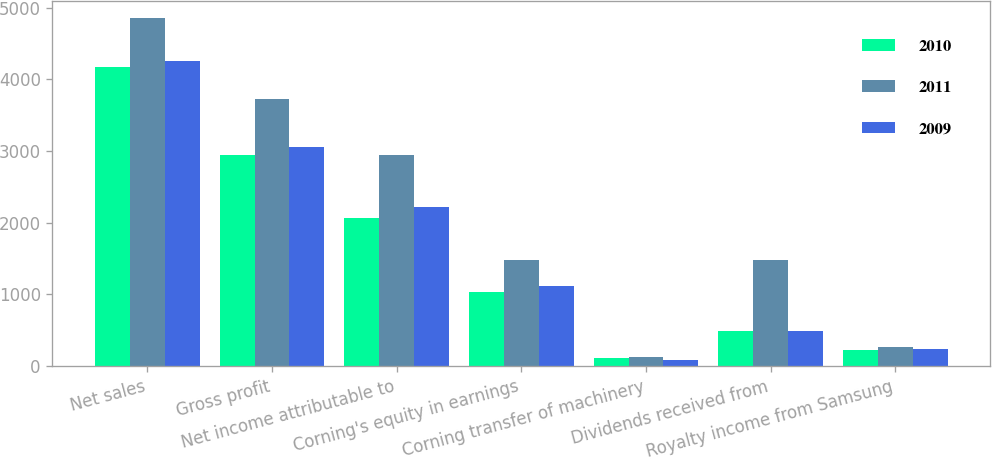Convert chart to OTSL. <chart><loc_0><loc_0><loc_500><loc_500><stacked_bar_chart><ecel><fcel>Net sales<fcel>Gross profit<fcel>Net income attributable to<fcel>Corning's equity in earnings<fcel>Corning transfer of machinery<fcel>Dividends received from<fcel>Royalty income from Samsung<nl><fcel>2010<fcel>4171<fcel>2942<fcel>2061<fcel>1031<fcel>113<fcel>492<fcel>219<nl><fcel>2011<fcel>4856<fcel>3731<fcel>2946<fcel>1473<fcel>121<fcel>1474<fcel>265<nl><fcel>2009<fcel>4250<fcel>3053<fcel>2212<fcel>1115<fcel>78<fcel>490<fcel>232<nl></chart> 